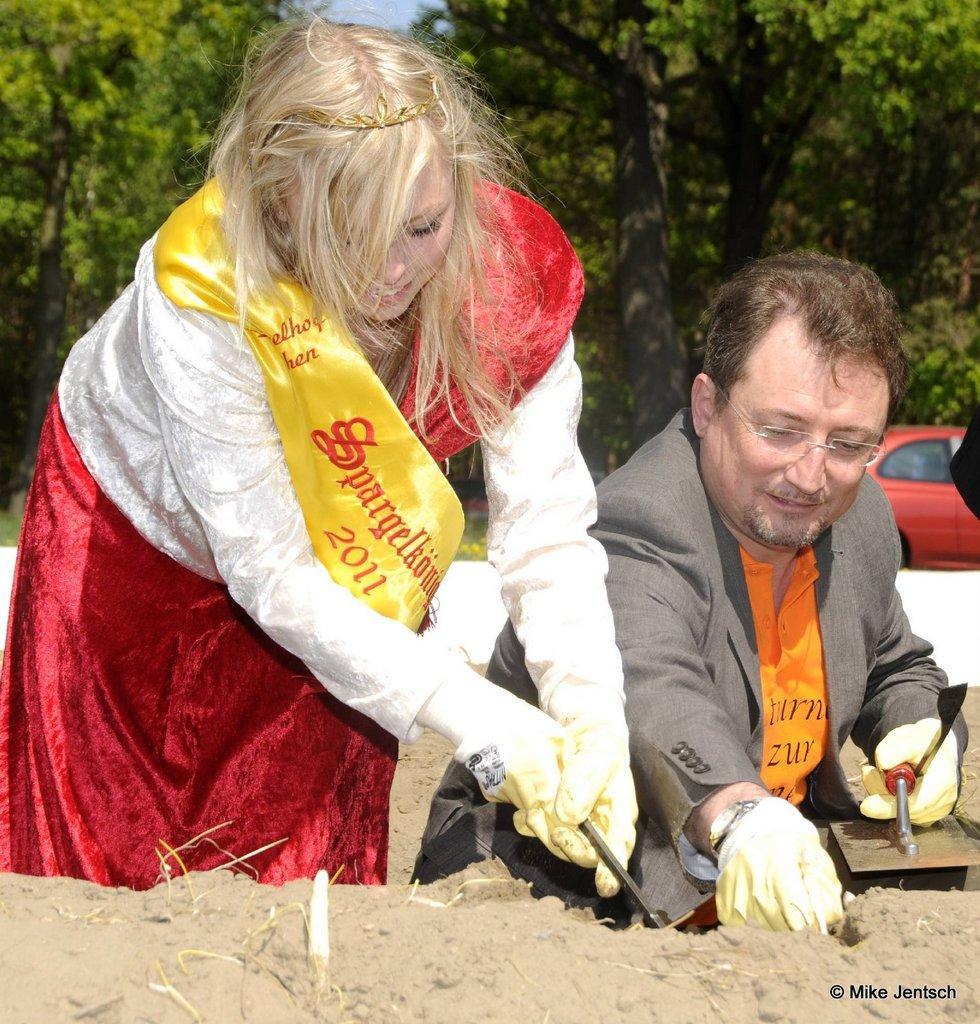Please provide a concise description of this image. In the picture we can see a man and woman sitting near the sand and a man is wearing a blazer with orange T-shirt and the woman is wearing a white dress with red skirt and some yellow cloth on it and they both are wearing gloves and working something in the sand and behind them we can see a car which is red in color and besides we can see trees. 